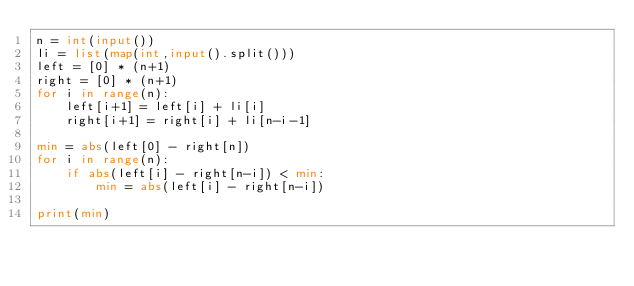<code> <loc_0><loc_0><loc_500><loc_500><_Python_>n = int(input())
li = list(map(int,input().split()))
left = [0] * (n+1)
right = [0] * (n+1)
for i in range(n):
    left[i+1] = left[i] + li[i]
    right[i+1] = right[i] + li[n-i-1]

min = abs(left[0] - right[n])
for i in range(n):
    if abs(left[i] - right[n-i]) < min:
        min = abs(left[i] - right[n-i])

print(min)
</code> 